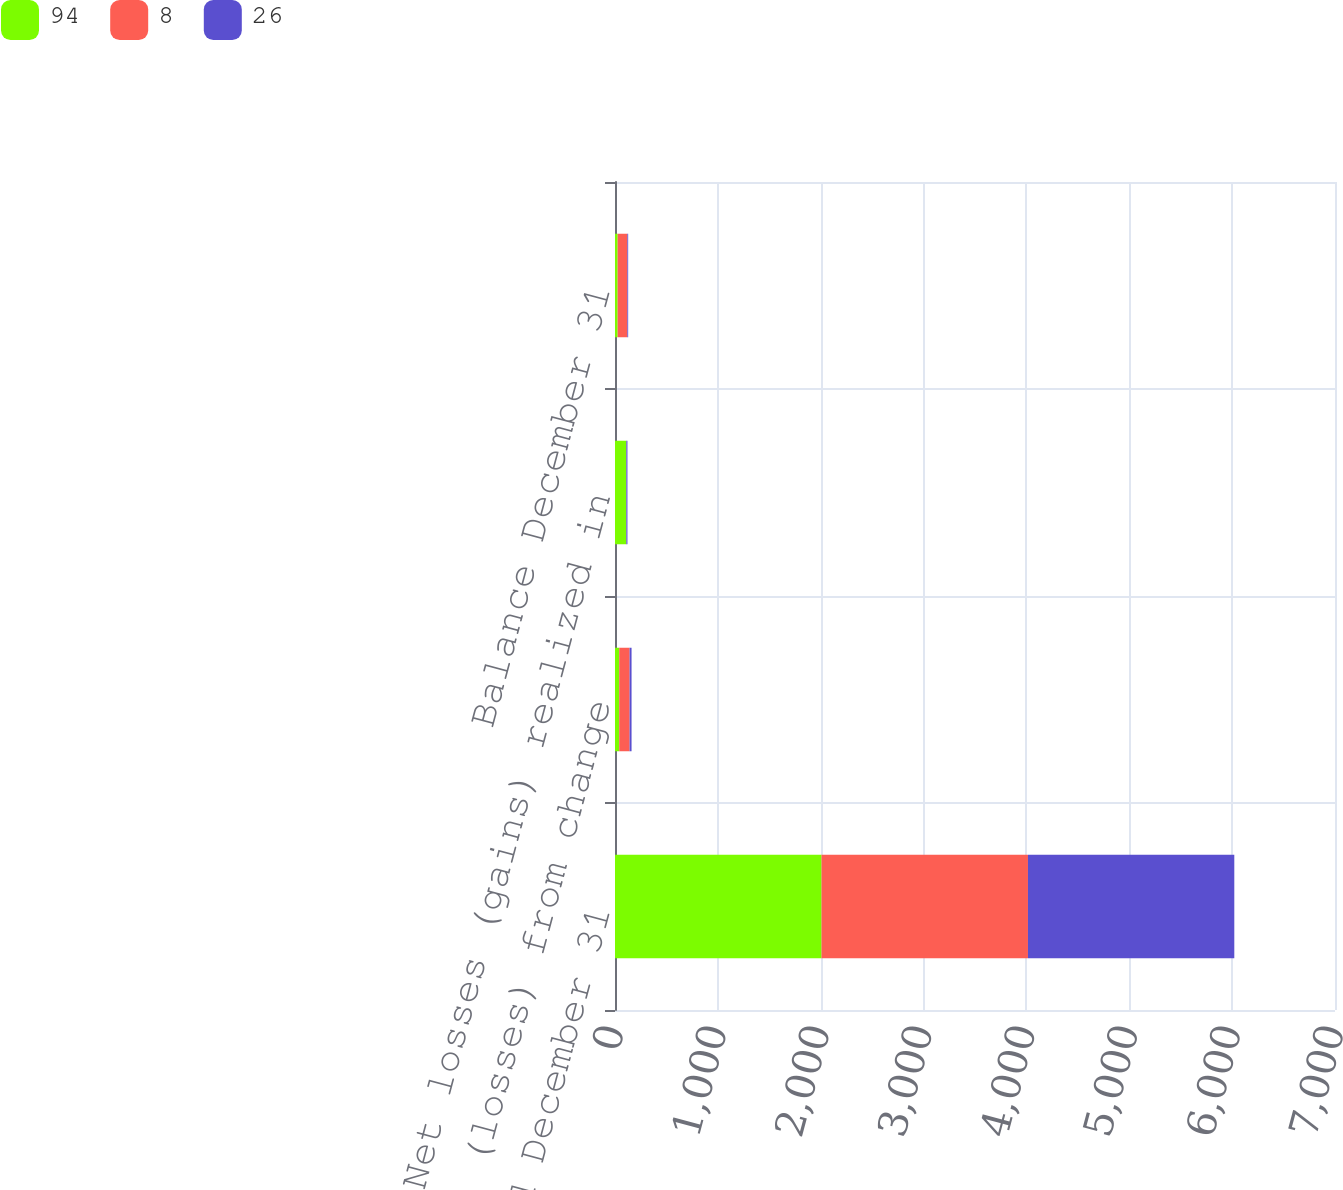Convert chart. <chart><loc_0><loc_0><loc_500><loc_500><stacked_bar_chart><ecel><fcel>Year Ended December 31<fcel>Net gains (losses) from change<fcel>Net losses (gains) realized in<fcel>Balance December 31<nl><fcel>94<fcel>2008<fcel>41<fcel>109<fcel>26<nl><fcel>8<fcel>2007<fcel>101<fcel>1<fcel>94<nl><fcel>26<fcel>2006<fcel>19<fcel>11<fcel>8<nl></chart> 